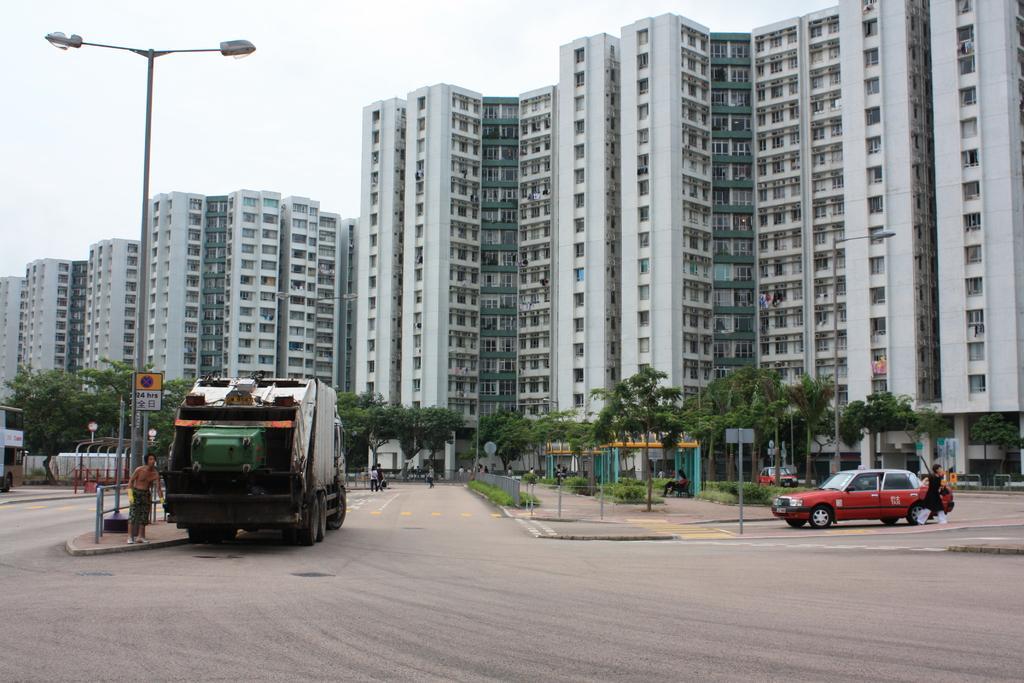In one or two sentences, can you explain what this image depicts? In this image we can see group of vehicles parked on the road. On the left side of the image we can see a sign board, light pole and a person standing on the path, metal barricade. On the right side of the image we can see a person wearing black dress. In the background, we can see a group of trees, buildings with windows and the sky. 